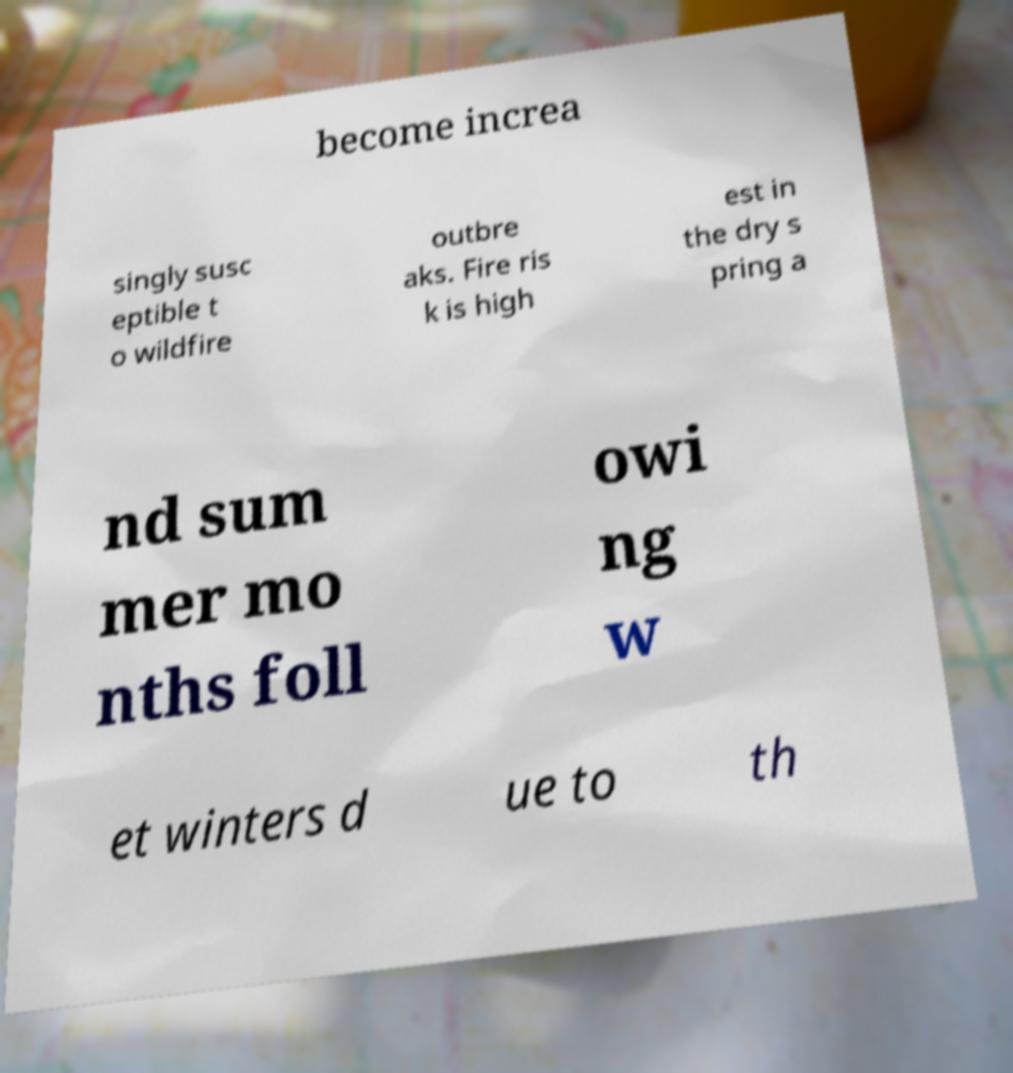Could you assist in decoding the text presented in this image and type it out clearly? become increa singly susc eptible t o wildfire outbre aks. Fire ris k is high est in the dry s pring a nd sum mer mo nths foll owi ng w et winters d ue to th 